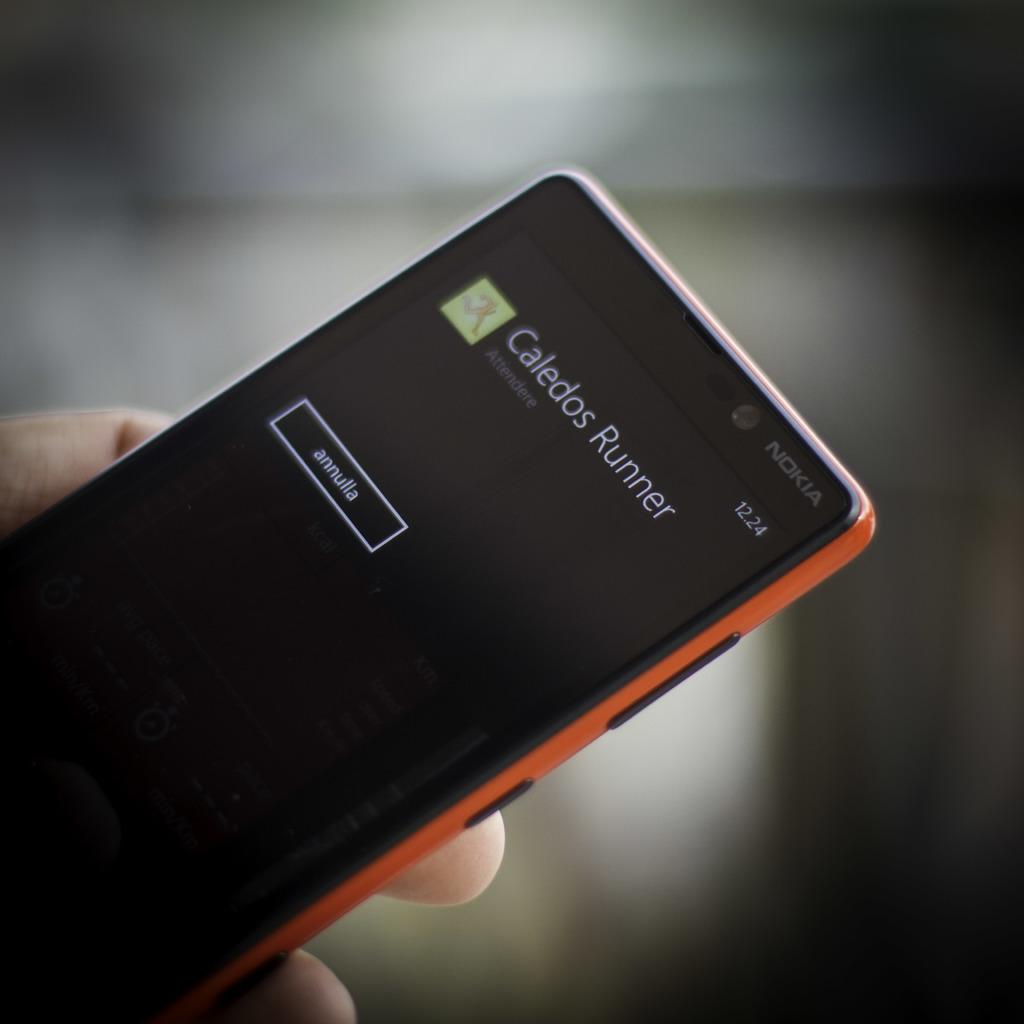<image>
Describe the image concisely. A Nokia smartphone with the Caledos Runner app install screen. 